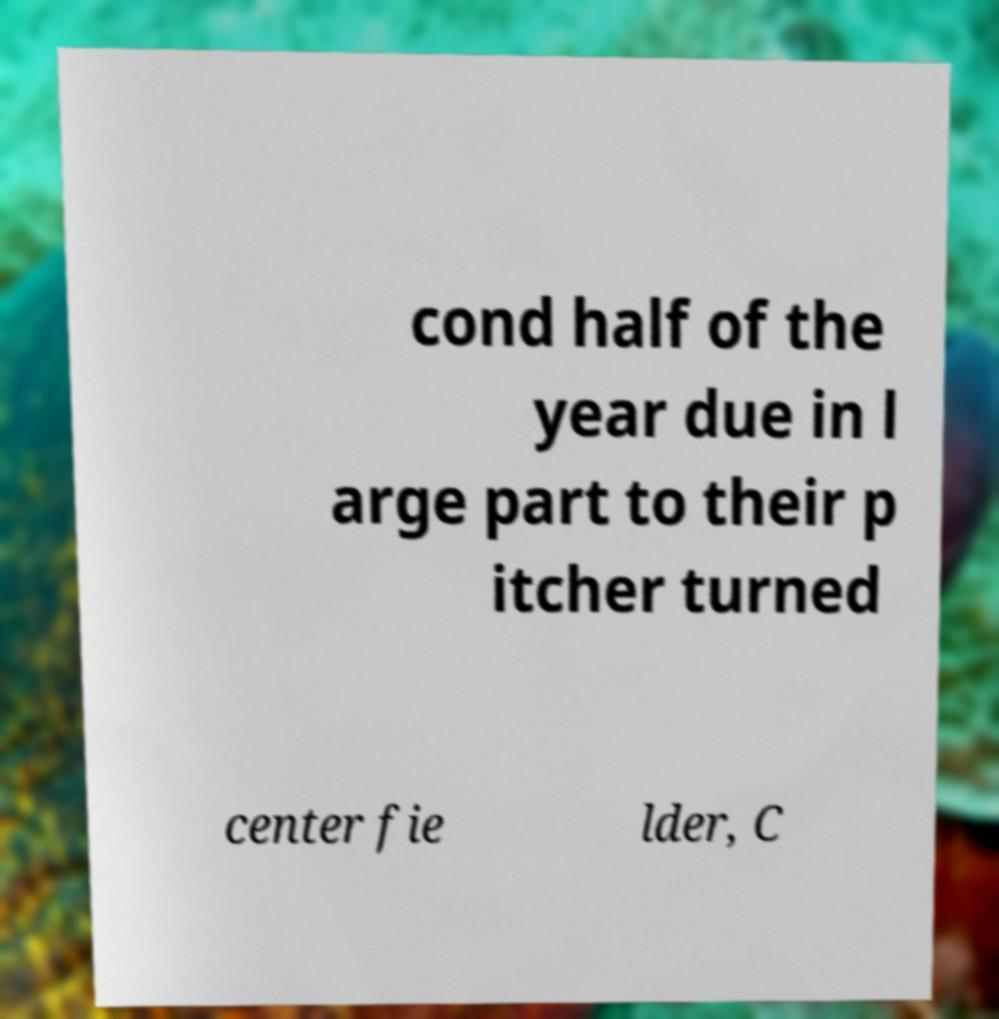For documentation purposes, I need the text within this image transcribed. Could you provide that? cond half of the year due in l arge part to their p itcher turned center fie lder, C 